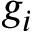<formula> <loc_0><loc_0><loc_500><loc_500>g _ { i }</formula> 